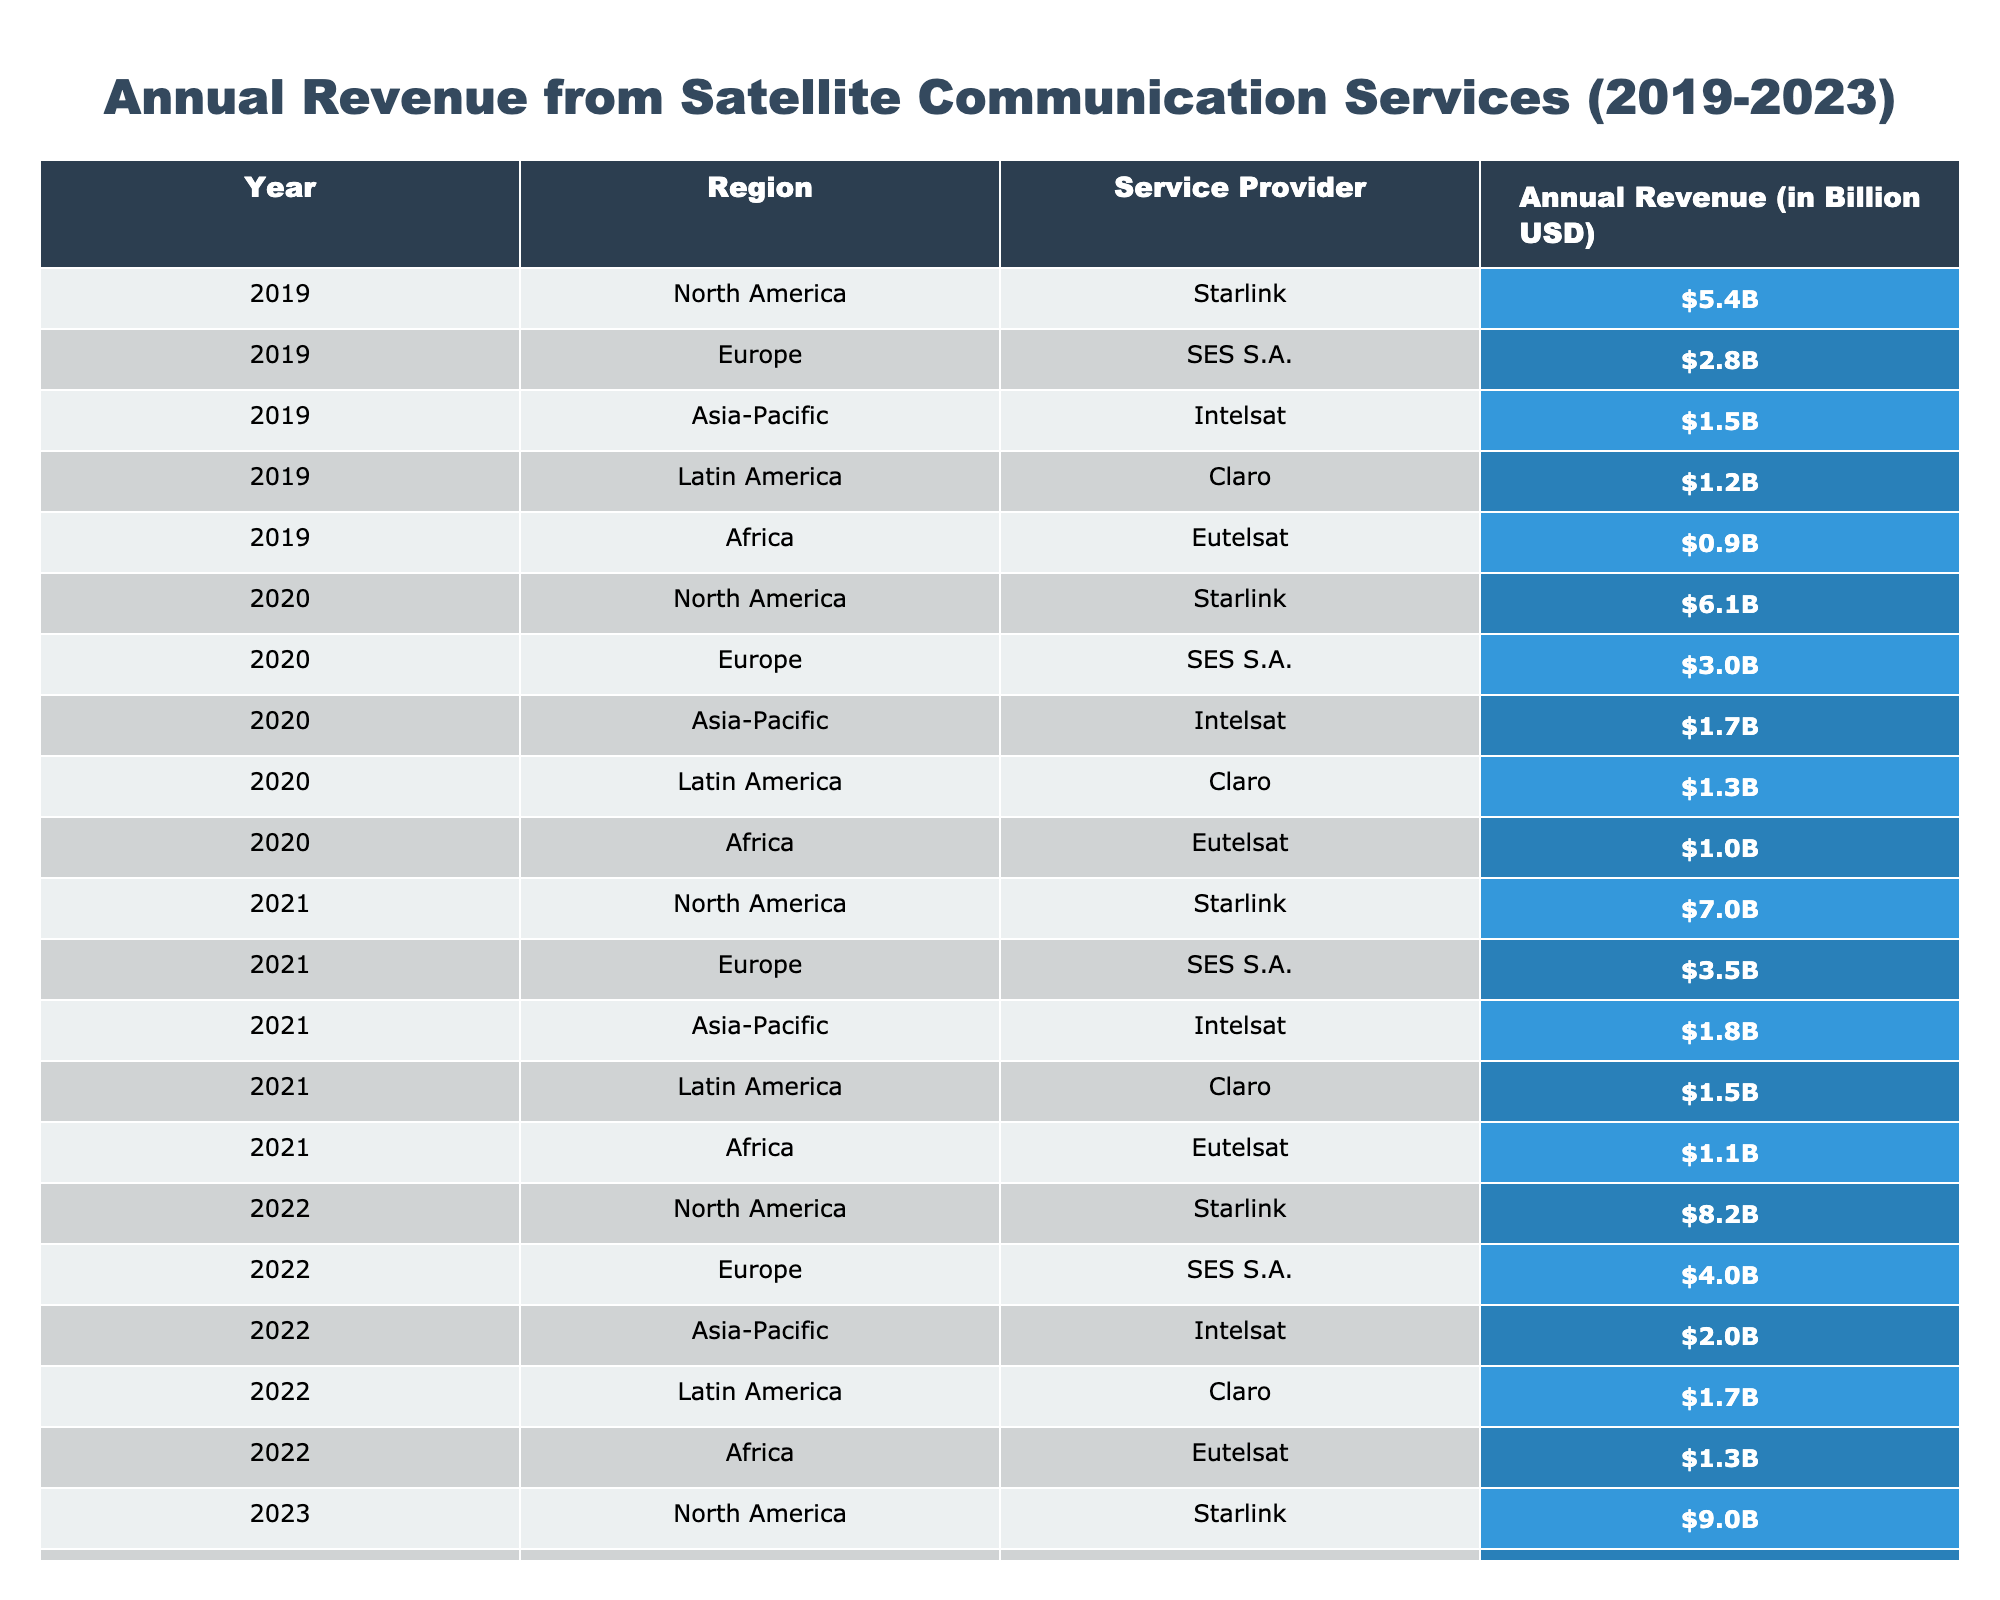What was the annual revenue for Starlink in 2022? In the table, under the year 2022, the annual revenue for Starlink is listed as $8.2 billion.
Answer: $8.2 billion Which region had the lowest annual revenue in 2019? In 2019, the annual revenue values for each region are: North America ($5.4B), Europe ($2.8B), Asia-Pacific ($1.5B), Latin America ($1.2B), and Africa ($0.9B). The lowest value is $0.9 billion, from Africa.
Answer: Africa What was the total annual revenue from satellite communication services in Asia-Pacific from 2019 to 2023? The annual revenues for Asia-Pacific over the years are: 2019 ($1.5B), 2020 ($1.7B), 2021 ($1.8B), 2022 ($2.0B), 2023 ($2.2B). Summing these gives: 1.5 + 1.7 + 1.8 + 2.0 + 2.2 = 9.2 billion.
Answer: $9.2 billion Was the annual revenue from SES S.A. in 2021 greater than that in 2020? In 2021, SES S.A. had an annual revenue of $3.5 billion, and in 2020, it was $3.0 billion. Since $3.5 billion is greater than $3.0 billion, the statement is true.
Answer: Yes What is the average annual revenue from Claro across the five years? The revenues from Claro are: 2019 ($1.2B), 2020 ($1.3B), 2021 ($1.5B), 2022 ($1.7B), 2023 ($1.9B). The sum is 1.2 + 1.3 + 1.5 + 1.7 + 1.9 = 7.6 billion. The average is 7.6/5 = 1.52 billion.
Answer: $1.52 billion In which year did Intelsat show its highest annual revenue? By looking at the revenues over the years for Intelsat, they are: 2019 ($1.5B), 2020 ($1.7B), 2021 ($1.8B), 2022 ($2.0B), and 2023 ($2.2B). The highest is $2.2 billion in 2023.
Answer: 2023 What is the difference in revenue for Starlink between 2019 and 2023? From the table, Starlink's revenues are: 2019 ($5.4B) and 2023 ($9.0B). The difference is $9.0B - $5.4B = $3.6 billion.
Answer: $3.6 billion Which service provider had the most significant increase in revenue from 2019 to 2023? Comparing the providers: Starlink increased from $5.4B to $9.0B (+$3.6B), SES S.A. from $2.8B to $4.5B (+$1.7B), Intelsat from $1.5B to $2.2B (+$0.7B), Claro from $1.2B to $1.9B (+$0.7B), and Eutelsat from $0.9B to $1.5B (+$0.6B). Starlink shows the largest increase, $3.6 billion.
Answer: Starlink What percentage of total revenue in 2023 was generated by North America? For 2023, total revenue sums to $9.0B (Starlink, North America), $4.5B (SES S.A.), $2.2B (Intelsat), $1.9B (Claro), and $1.5B (Eutelsat), equating to $19.1 billion. North America contributes $9.0 billion. The percentage is (9.0 / 19.1) * 100 = approximately 47.1%.
Answer: 47.1% What is the trend in annual revenue for SES S.A. from 2019 to 2023? The revenues from SES S.A. are: 2019 ($2.8B), 2020 ($3.0B), 2021 ($3.5B), 2022 ($4.0B), and 2023 ($4.5B). Observing these values indicates consistent growth each year.
Answer: Consistent growth 